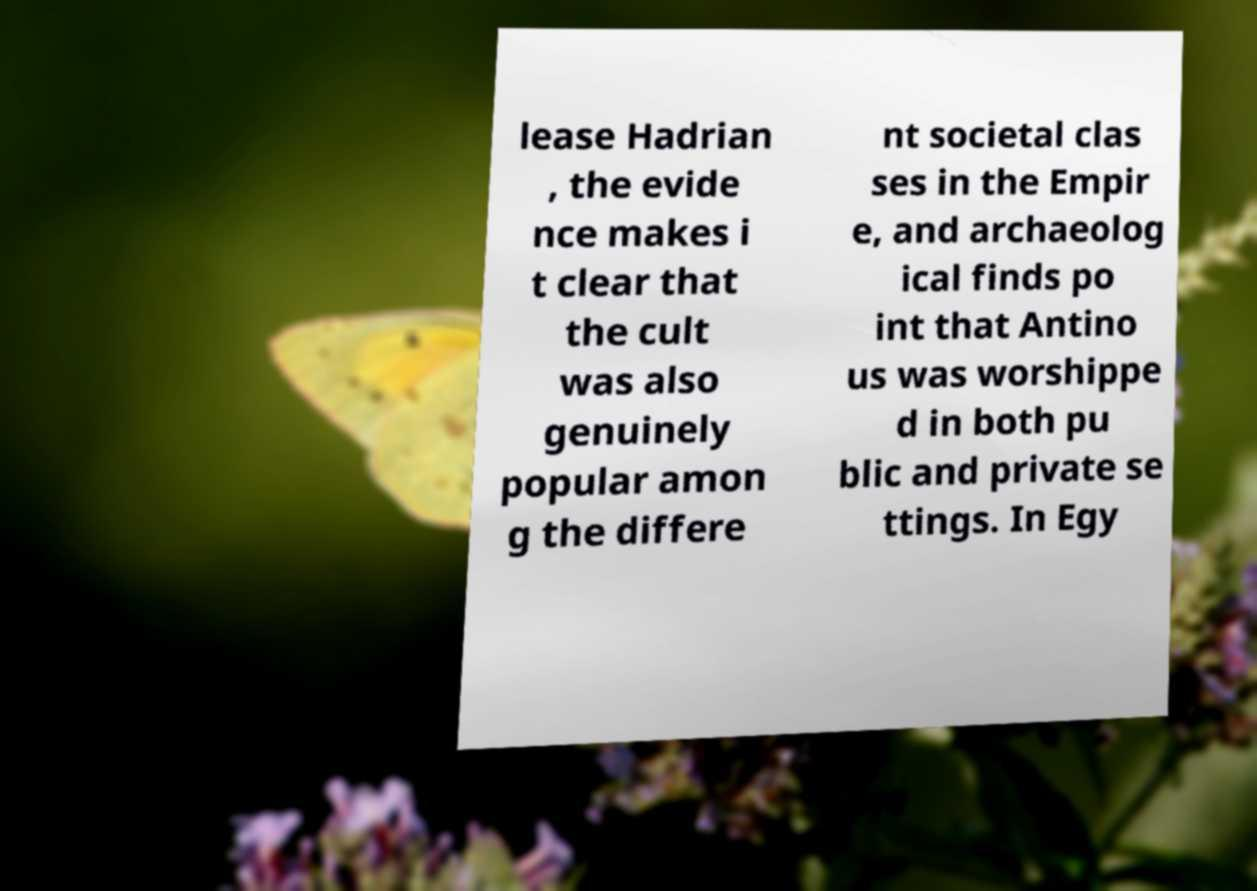Please identify and transcribe the text found in this image. lease Hadrian , the evide nce makes i t clear that the cult was also genuinely popular amon g the differe nt societal clas ses in the Empir e, and archaeolog ical finds po int that Antino us was worshippe d in both pu blic and private se ttings. In Egy 